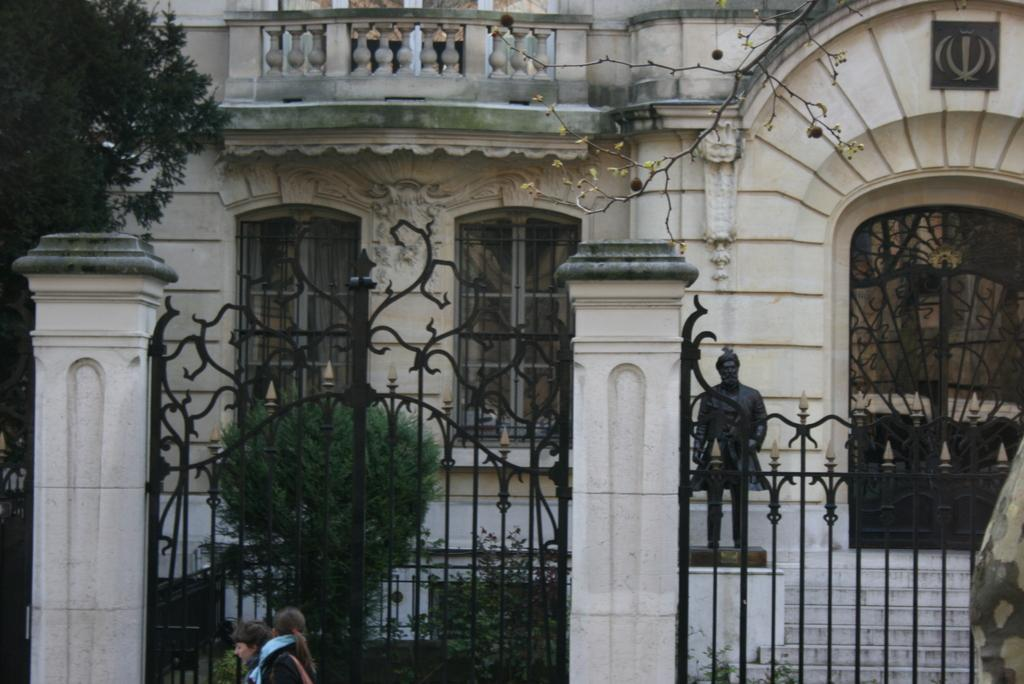How many people are present in the image? There are two people in the image. What architectural features can be seen in the image? There are gates, pillars, and steps visible in the image. What type of vegetation is present in the image? There are plants and trees in the image. What additional object can be seen in the image? There is a statue in the image. What is visible in the background of the image? There is a building with windows in the background of the image. What type of rabbit can be seen in the middle of the image? There is no rabbit present in the image. Is there a birthday celebration happening in the image? There is no indication of a birthday celebration in the image. 